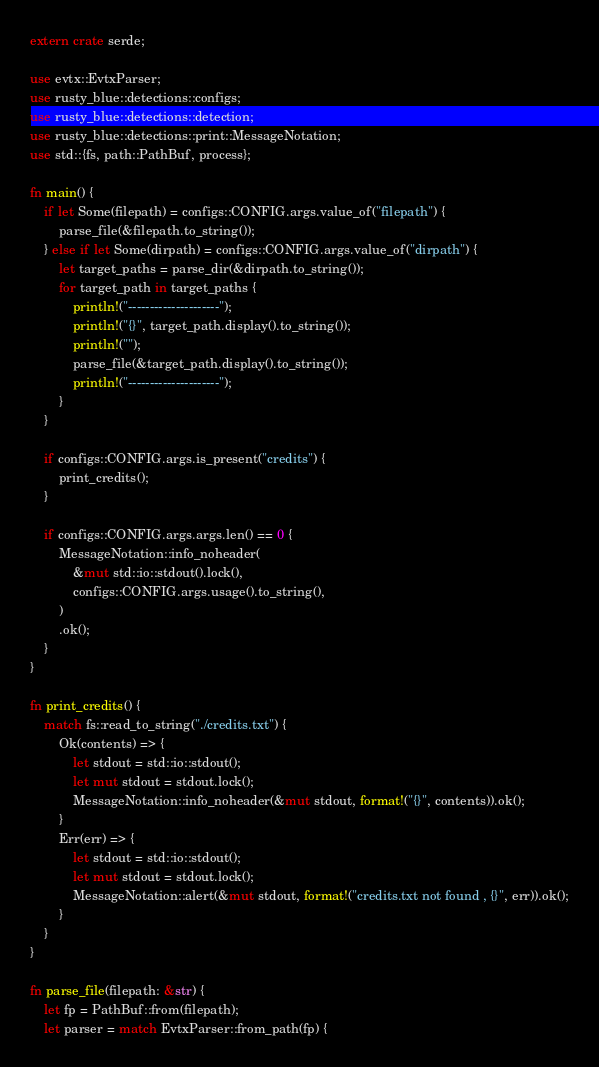<code> <loc_0><loc_0><loc_500><loc_500><_Rust_>extern crate serde;

use evtx::EvtxParser;
use rusty_blue::detections::configs;
use rusty_blue::detections::detection;
use rusty_blue::detections::print::MessageNotation;
use std::{fs, path::PathBuf, process};

fn main() {
    if let Some(filepath) = configs::CONFIG.args.value_of("filepath") {
        parse_file(&filepath.to_string());
    } else if let Some(dirpath) = configs::CONFIG.args.value_of("dirpath") {
        let target_paths = parse_dir(&dirpath.to_string());
        for target_path in target_paths {
            println!("---------------------");
            println!("{}", target_path.display().to_string());
            println!("");
            parse_file(&target_path.display().to_string());
            println!("---------------------");
        }
    }

    if configs::CONFIG.args.is_present("credits") {
        print_credits();
    }

    if configs::CONFIG.args.args.len() == 0 {
        MessageNotation::info_noheader(
            &mut std::io::stdout().lock(),
            configs::CONFIG.args.usage().to_string(),
        )
        .ok();
    }
}

fn print_credits() {
    match fs::read_to_string("./credits.txt") {
        Ok(contents) => {
            let stdout = std::io::stdout();
            let mut stdout = stdout.lock();
            MessageNotation::info_noheader(&mut stdout, format!("{}", contents)).ok();
        }
        Err(err) => {
            let stdout = std::io::stdout();
            let mut stdout = stdout.lock();
            MessageNotation::alert(&mut stdout, format!("credits.txt not found , {}", err)).ok();
        }
    }
}

fn parse_file(filepath: &str) {
    let fp = PathBuf::from(filepath);
    let parser = match EvtxParser::from_path(fp) {</code> 